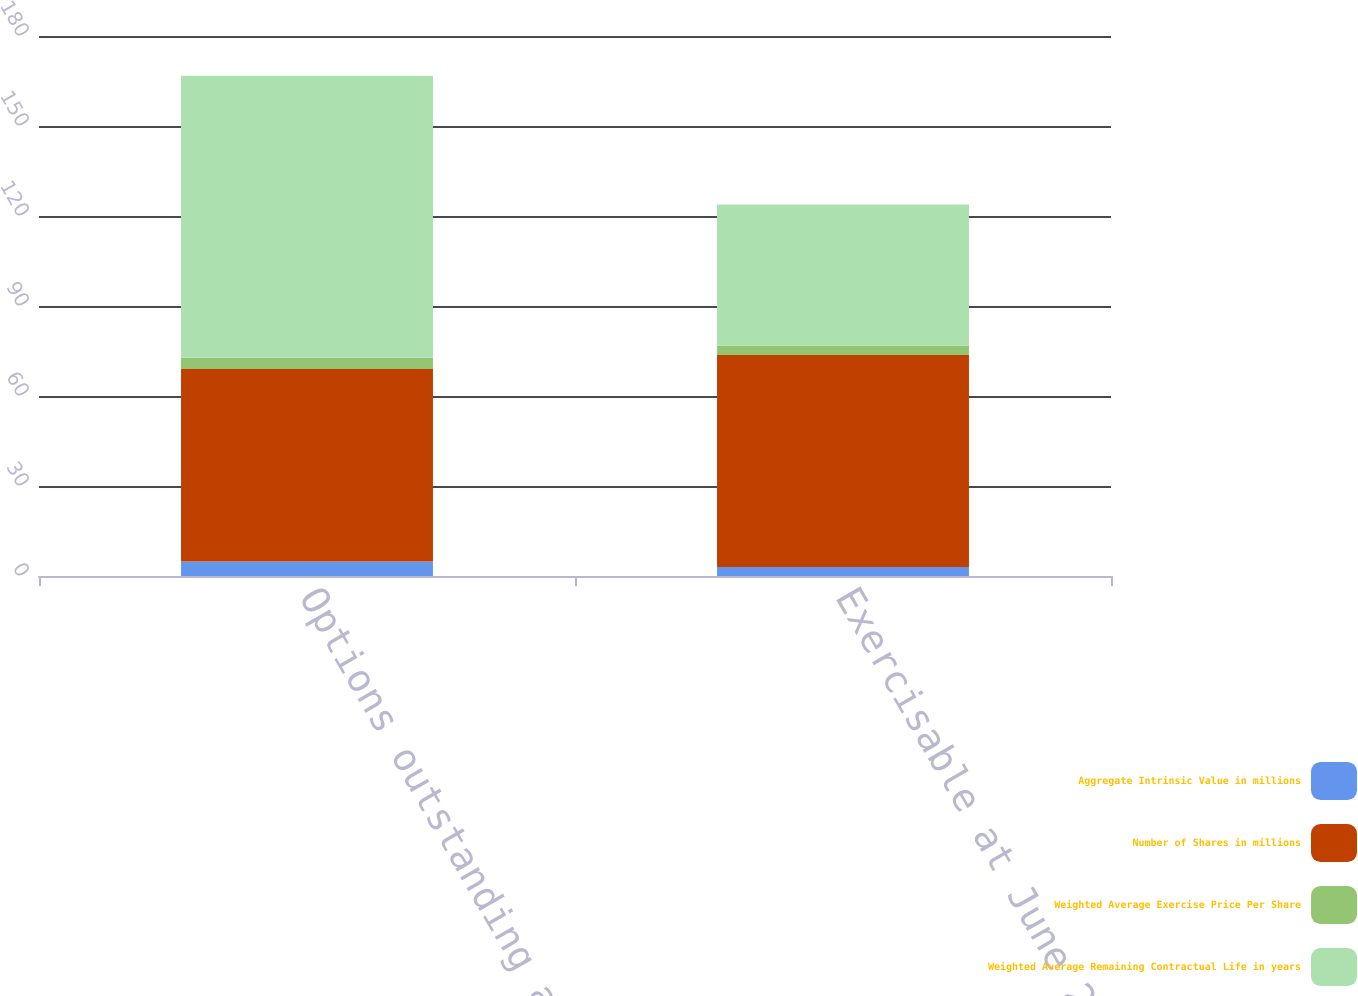Convert chart. <chart><loc_0><loc_0><loc_500><loc_500><stacked_bar_chart><ecel><fcel>Options outstanding at June 29<fcel>Exercisable at June 29 2018<nl><fcel>Aggregate Intrinsic Value in millions<fcel>4.8<fcel>3<nl><fcel>Number of Shares in millions<fcel>64.23<fcel>70.7<nl><fcel>Weighted Average Exercise Price Per Share<fcel>3.7<fcel>3.1<nl><fcel>Weighted Average Remaining Contractual Life in years<fcel>94<fcel>47<nl></chart> 